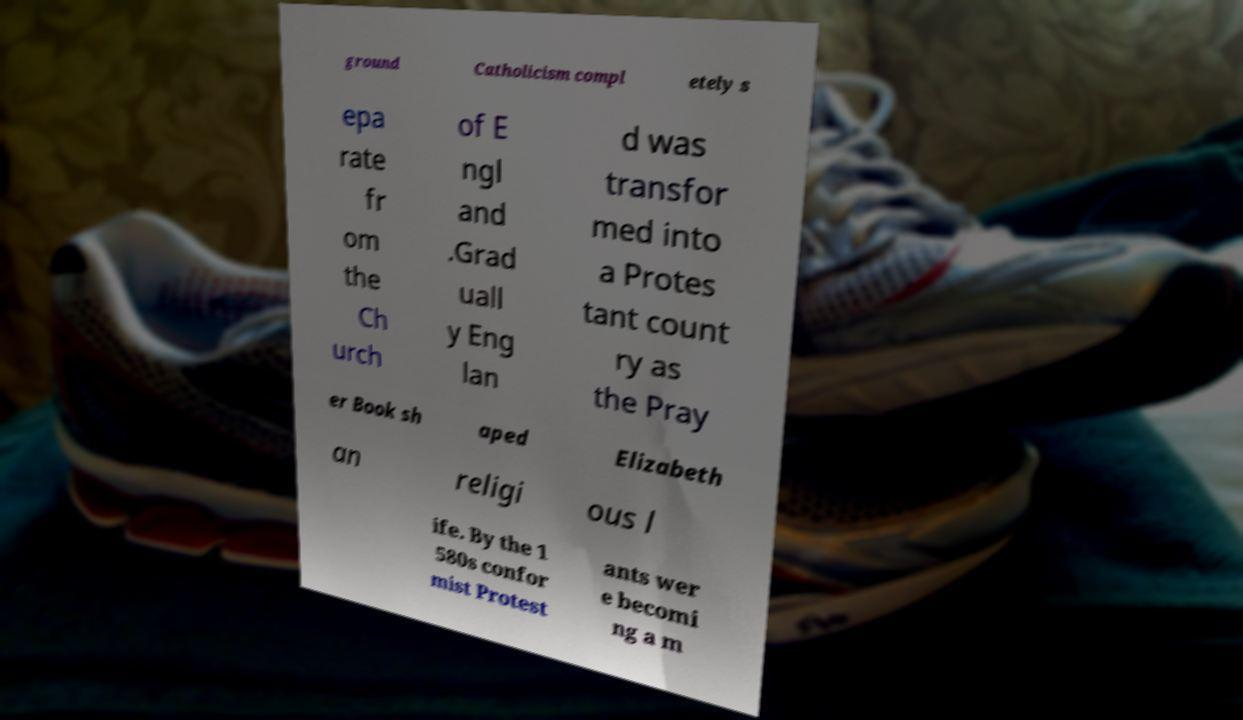Could you assist in decoding the text presented in this image and type it out clearly? ground Catholicism compl etely s epa rate fr om the Ch urch of E ngl and .Grad uall y Eng lan d was transfor med into a Protes tant count ry as the Pray er Book sh aped Elizabeth an religi ous l ife. By the 1 580s confor mist Protest ants wer e becomi ng a m 